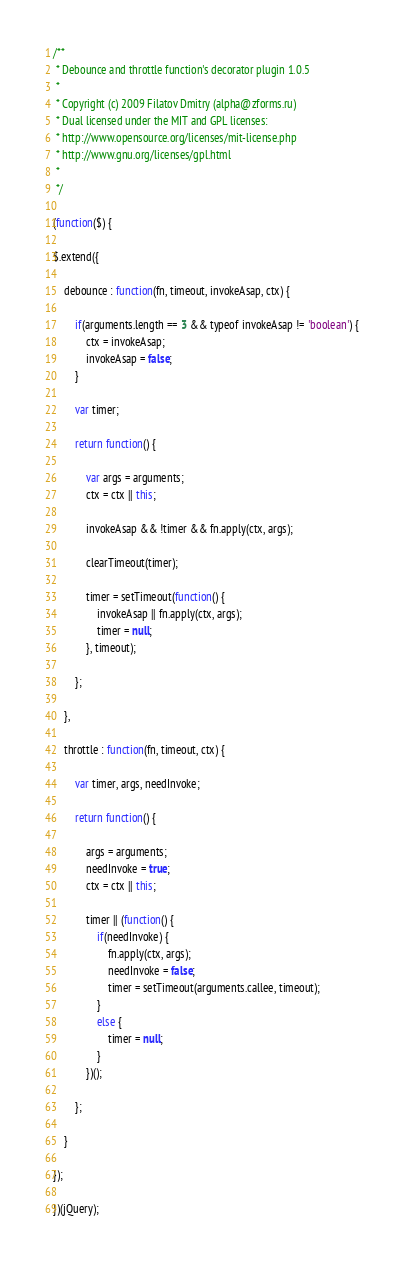<code> <loc_0><loc_0><loc_500><loc_500><_JavaScript_>/**
 * Debounce and throttle function's decorator plugin 1.0.5
 *
 * Copyright (c) 2009 Filatov Dmitry (alpha@zforms.ru)
 * Dual licensed under the MIT and GPL licenses:
 * http://www.opensource.org/licenses/mit-license.php
 * http://www.gnu.org/licenses/gpl.html
 *
 */

(function($) {

$.extend({

	debounce : function(fn, timeout, invokeAsap, ctx) {

		if(arguments.length == 3 && typeof invokeAsap != 'boolean') {
			ctx = invokeAsap;
			invokeAsap = false;
		}

		var timer;

		return function() {

			var args = arguments;
			ctx = ctx || this;

			invokeAsap && !timer && fn.apply(ctx, args);

			clearTimeout(timer);

			timer = setTimeout(function() {
				invokeAsap || fn.apply(ctx, args);
				timer = null;
			}, timeout);

		};

	},

	throttle : function(fn, timeout, ctx) {

		var timer, args, needInvoke;

		return function() {

			args = arguments;
			needInvoke = true;
			ctx = ctx || this;

			timer || (function() {
				if(needInvoke) {
					fn.apply(ctx, args);
					needInvoke = false;
					timer = setTimeout(arguments.callee, timeout);
				}
				else {
					timer = null;
				}
			})();

		};

	}

});

})(jQuery);
</code> 